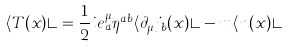<formula> <loc_0><loc_0><loc_500><loc_500>\langle T ( x ) \rangle = \frac { 1 } { 2 } i e _ { a } ^ { \mu } \eta ^ { a b } \langle \partial _ { \mu } j _ { b } ( x ) \rangle - m \langle n ( x ) \rangle</formula> 